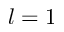<formula> <loc_0><loc_0><loc_500><loc_500>l = 1</formula> 